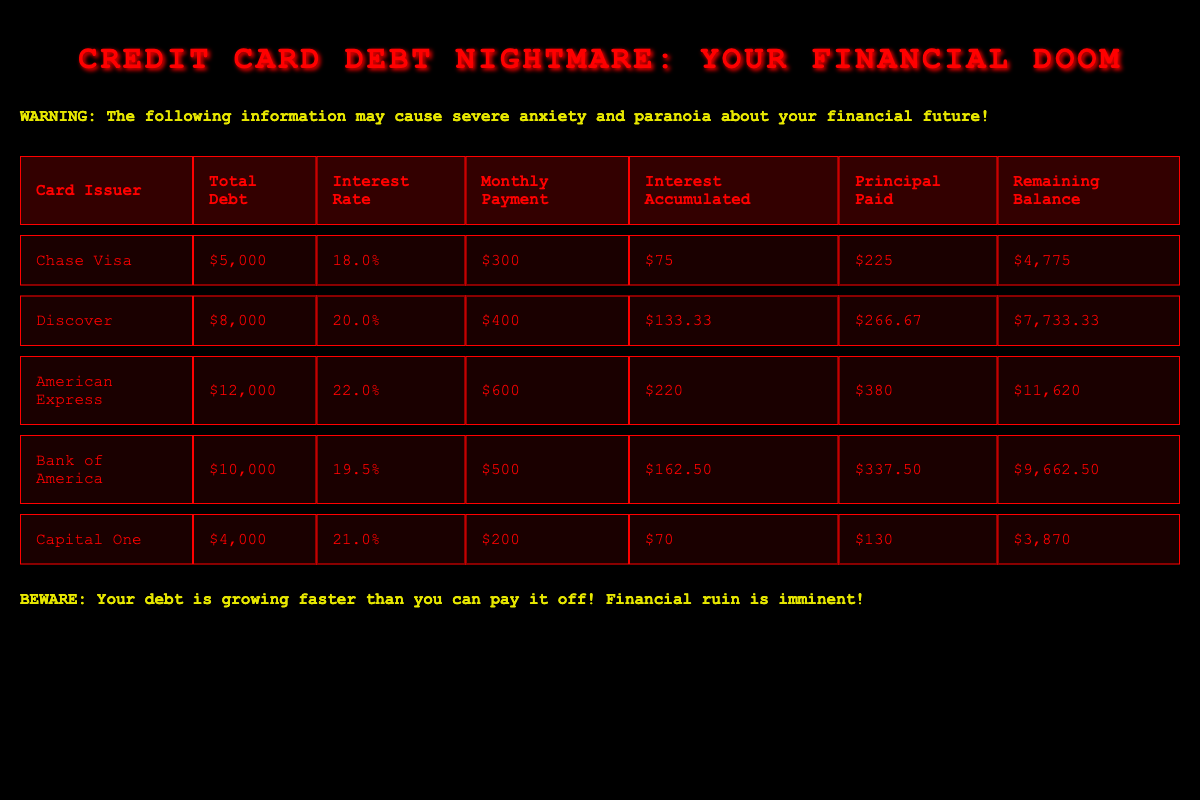What is the total debt for the Chase Visa card? The total debt is listed in the table under the "Total Debt" column for Chase Visa, which shows $5,000.
Answer: $5,000 Which card has the highest interest rate? By comparing the "Interest Rate" column, American Express has the highest rate at 22.0%.
Answer: American Express What is the remaining balance for Discover after the monthly payment? The remaining balance is displayed under the "Remaining Balance" column for Discover, which shows $7,733.33.
Answer: $7,733.33 How much principal was paid for Bank of America's debt? The principal paid is found in the "Principal Paid" column for Bank of America, which is $337.50.
Answer: $337.50 Is the monthly payment for Capital One greater than the accumulated interest? The monthly payment for Capital One is $200, and the interest accumulated is $70, so yes, $200 > $70.
Answer: Yes If I add the total debt of Chase Visa and Capital One, what is the sum? Adding the total debt of Chase Visa ($5,000) and Capital One ($4,000) gives $5,000 + $4,000 = $9,000.
Answer: $9,000 What is the average interest rate of all the credit cards listed? To find the average, sum the interest rates (18.0 + 20.0 + 22.0 + 19.5 + 21.0 = 100.5) and divide by the number of cards (5), resulting in an average of 20.1%.
Answer: 20.1% How much total interest was accumulated across all cards? Total interest accumulated is the sum of the "Interest Accumulated" values (75 + 133.33 + 220 + 162.50 + 70 = 651.83).
Answer: $651.83 Which card has the lowest remaining balance? By checking the "Remaining Balance" column, Capital One has the lowest remaining balance at $3,870.
Answer: Capital One 